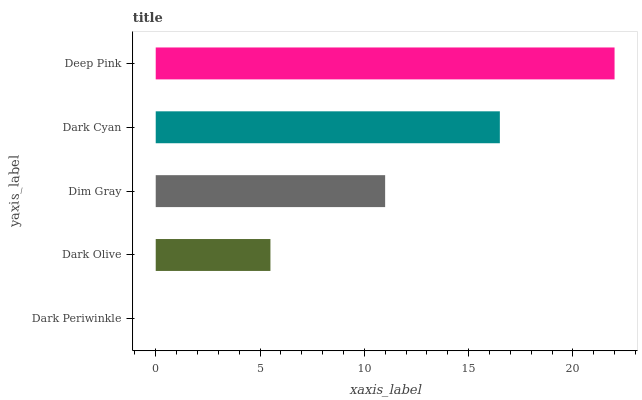Is Dark Periwinkle the minimum?
Answer yes or no. Yes. Is Deep Pink the maximum?
Answer yes or no. Yes. Is Dark Olive the minimum?
Answer yes or no. No. Is Dark Olive the maximum?
Answer yes or no. No. Is Dark Olive greater than Dark Periwinkle?
Answer yes or no. Yes. Is Dark Periwinkle less than Dark Olive?
Answer yes or no. Yes. Is Dark Periwinkle greater than Dark Olive?
Answer yes or no. No. Is Dark Olive less than Dark Periwinkle?
Answer yes or no. No. Is Dim Gray the high median?
Answer yes or no. Yes. Is Dim Gray the low median?
Answer yes or no. Yes. Is Dark Periwinkle the high median?
Answer yes or no. No. Is Deep Pink the low median?
Answer yes or no. No. 